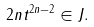Convert formula to latex. <formula><loc_0><loc_0><loc_500><loc_500>2 n t ^ { 2 n - 2 } \in J .</formula> 